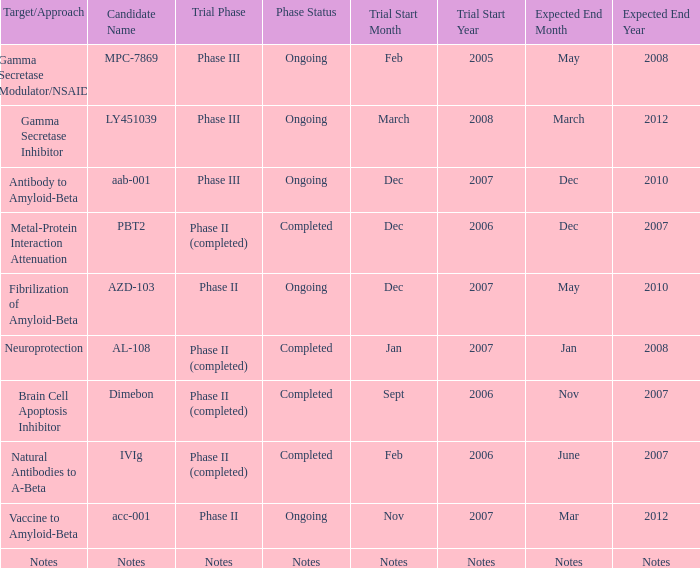When the candidate's name is notes, what is the start date of the trial? Notes. 